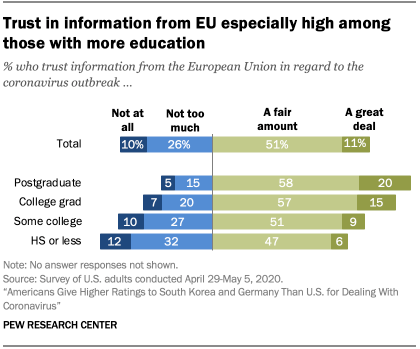Indicate a few pertinent items in this graphic. The ratio of the two lowest values of the bars A:B is 0.085416667... According to a survey, 15% of college graduates trust information to a great deal. 